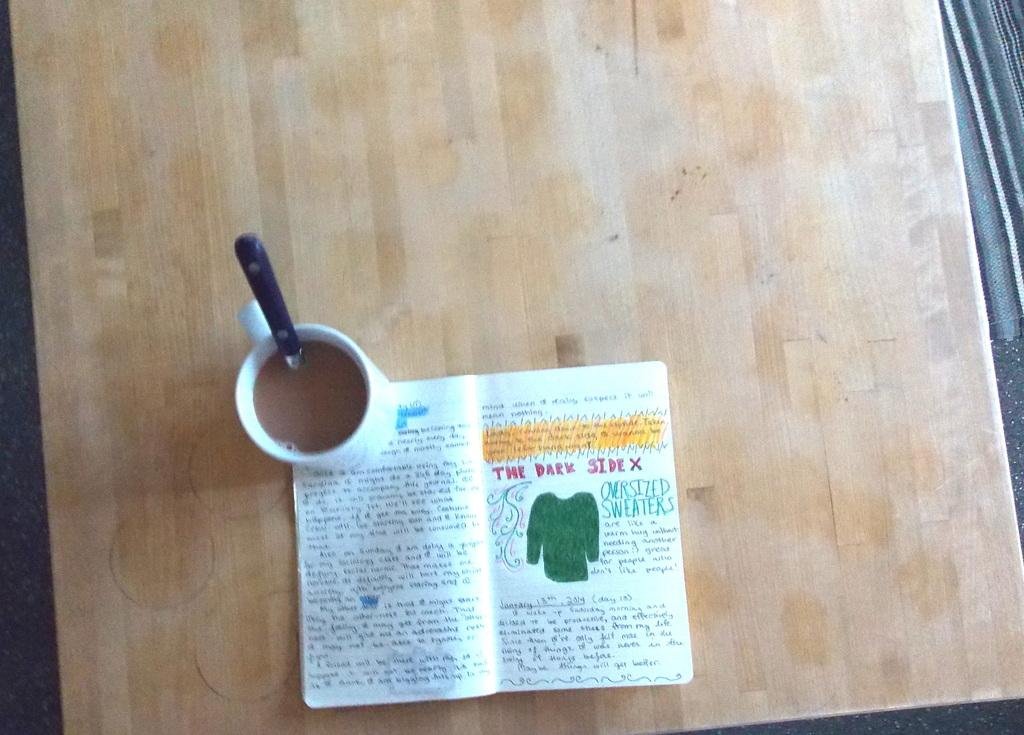<image>
Describe the image concisely. A coffee mug and a journal doodle book about the dark side and oversized sweaters. 